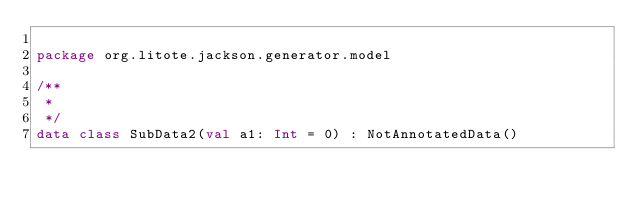<code> <loc_0><loc_0><loc_500><loc_500><_Kotlin_>
package org.litote.jackson.generator.model

/**
 *
 */
data class SubData2(val a1: Int = 0) : NotAnnotatedData()</code> 